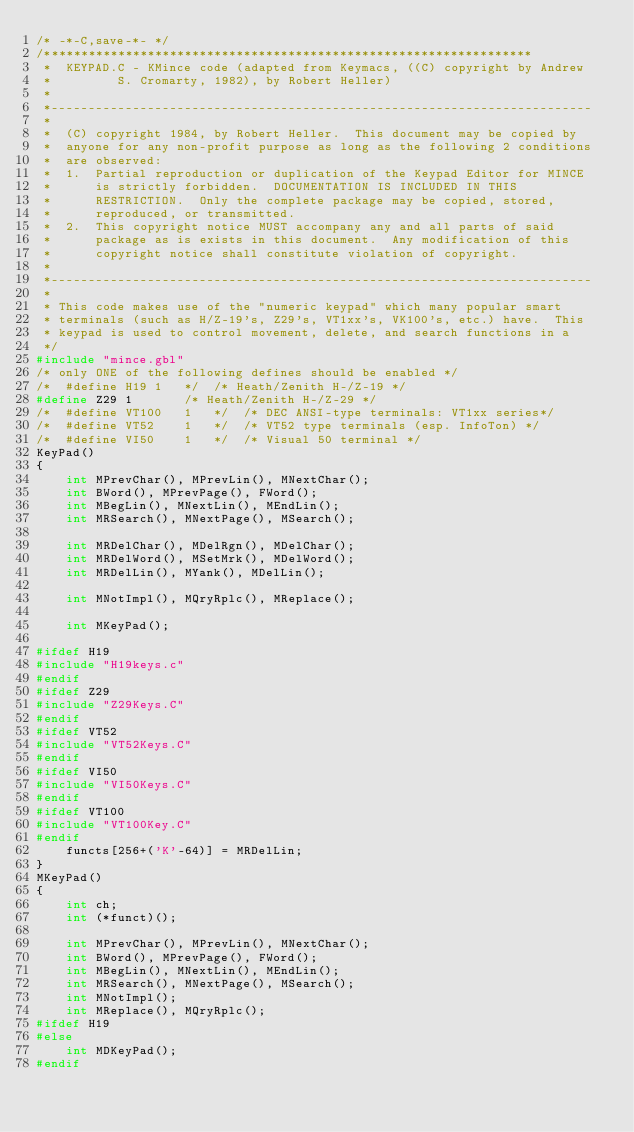Convert code to text. <code><loc_0><loc_0><loc_500><loc_500><_C_>/* -*-C,save-*- */
/******************************************************************
 *	KEYPAD.C - KMince code (adapted from Keymacs, ((C) copyright by Andrew
 *		   S. Cromarty, 1982), by Robert Heller)
 *
 *-------------------------------------------------------------------------
 *
 *	(C) copyright 1984, by Robert Heller.  This document may be copied by
 *	anyone for any non-profit purpose as long as the following 2 conditions
 *	are observed:
 *	1.  Partial reproduction or duplication of the Keypad Editor for MINCE
 *	    is strictly forbidden.  DOCUMENTATION IS INCLUDED IN THIS
 *	    RESTRICTION.  Only the complete package may be copied, stored,
 *	    reproduced, or transmitted.
 *	2.  This copyright notice MUST accompany any and all parts of said
 *	    package as is exists in this document.  Any modification of this
 *	    copyright notice shall constitute violation of copyright.
 *
 *-------------------------------------------------------------------------
 *
 * This code makes use of the "numeric keypad" which many popular smart 
 * terminals (such as H/Z-19's, Z29's, VT1xx's, VK100's, etc.) have.  This 
 * keypad is used to control movement, delete, and search functions in a
 */
#include "mince.gbl"
/* only ONE of the following defines should be enabled */
/*	#define H19	1	*/	/* Heath/Zenith H-/Z-19 */
#define Z29	1		/* Heath/Zenith H-/Z-29 */
/*	#define VT100	1	*/	/* DEC ANSI-type terminals: VT1xx series*/
/*	#define VT52	1	*/	/* VT52 type terminals (esp. InfoTon) */
/*	#define VI50	1	*/	/* Visual 50 terminal */
KeyPad()
{
	int MPrevChar(), MPrevLin(), MNextChar();
	int BWord(), MPrevPage(), FWord();
	int MBegLin(), MNextLin(), MEndLin();
	int MRSearch(), MNextPage(), MSearch();

	int MRDelChar(), MDelRgn(), MDelChar();
	int MRDelWord(), MSetMrk(), MDelWord();
	int MRDelLin(), MYank(), MDelLin();

	int MNotImpl(), MQryRplc(), MReplace();

	int MKeyPad();

#ifdef H19
#include "H19keys.c"
#endif
#ifdef Z29
#include "Z29Keys.C"
#endif
#ifdef VT52
#include "VT52Keys.C"
#endif
#ifdef VI50
#include "VI50Keys.C"
#endif
#ifdef VT100
#include "VT100Key.C"
#endif
	functs[256+('K'-64)] = MRDelLin;
}
MKeyPad()
{
	int ch;
	int (*funct)();

	int MPrevChar(), MPrevLin(), MNextChar();
	int BWord(), MPrevPage(), FWord();
	int MBegLin(), MNextLin(), MEndLin();
	int MRSearch(), MNextPage(), MSearch();
	int MNotImpl();
	int MReplace(), MQryRplc();
#ifdef H19
#else
	int MDKeyPad();
#endif
</code> 